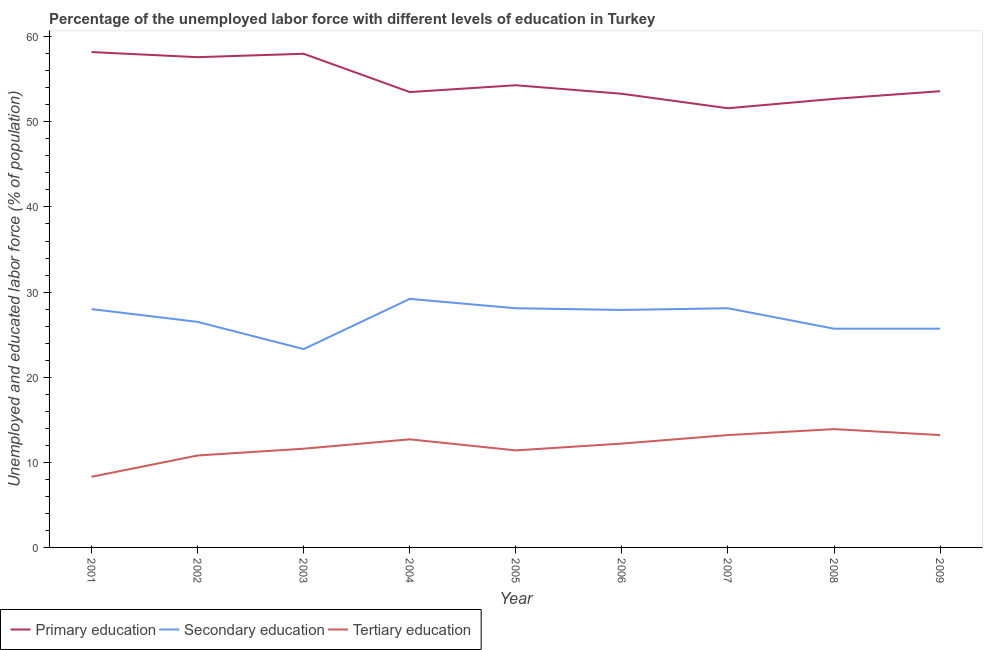How many different coloured lines are there?
Keep it short and to the point. 3. What is the percentage of labor force who received primary education in 2009?
Ensure brevity in your answer.  53.6. Across all years, what is the maximum percentage of labor force who received secondary education?
Keep it short and to the point. 29.2. Across all years, what is the minimum percentage of labor force who received primary education?
Make the answer very short. 51.6. In which year was the percentage of labor force who received primary education maximum?
Give a very brief answer. 2001. In which year was the percentage of labor force who received secondary education minimum?
Your response must be concise. 2003. What is the total percentage of labor force who received secondary education in the graph?
Provide a succinct answer. 242.5. What is the difference between the percentage of labor force who received secondary education in 2001 and that in 2003?
Provide a succinct answer. 4.7. What is the difference between the percentage of labor force who received primary education in 2008 and the percentage of labor force who received tertiary education in 2001?
Offer a terse response. 44.4. What is the average percentage of labor force who received tertiary education per year?
Keep it short and to the point. 11.92. In the year 2001, what is the difference between the percentage of labor force who received secondary education and percentage of labor force who received tertiary education?
Give a very brief answer. 19.7. What is the ratio of the percentage of labor force who received secondary education in 2001 to that in 2005?
Your answer should be very brief. 1. What is the difference between the highest and the second highest percentage of labor force who received secondary education?
Give a very brief answer. 1.1. What is the difference between the highest and the lowest percentage of labor force who received secondary education?
Offer a very short reply. 5.9. In how many years, is the percentage of labor force who received secondary education greater than the average percentage of labor force who received secondary education taken over all years?
Your response must be concise. 5. Is the sum of the percentage of labor force who received primary education in 2001 and 2004 greater than the maximum percentage of labor force who received secondary education across all years?
Ensure brevity in your answer.  Yes. Is it the case that in every year, the sum of the percentage of labor force who received primary education and percentage of labor force who received secondary education is greater than the percentage of labor force who received tertiary education?
Give a very brief answer. Yes. Does the percentage of labor force who received tertiary education monotonically increase over the years?
Your answer should be compact. No. Is the percentage of labor force who received tertiary education strictly less than the percentage of labor force who received secondary education over the years?
Make the answer very short. Yes. What is the difference between two consecutive major ticks on the Y-axis?
Ensure brevity in your answer.  10. Are the values on the major ticks of Y-axis written in scientific E-notation?
Keep it short and to the point. No. What is the title of the graph?
Keep it short and to the point. Percentage of the unemployed labor force with different levels of education in Turkey. Does "Machinery" appear as one of the legend labels in the graph?
Keep it short and to the point. No. What is the label or title of the X-axis?
Your response must be concise. Year. What is the label or title of the Y-axis?
Give a very brief answer. Unemployed and educated labor force (% of population). What is the Unemployed and educated labor force (% of population) of Primary education in 2001?
Provide a succinct answer. 58.2. What is the Unemployed and educated labor force (% of population) of Secondary education in 2001?
Your response must be concise. 28. What is the Unemployed and educated labor force (% of population) in Tertiary education in 2001?
Make the answer very short. 8.3. What is the Unemployed and educated labor force (% of population) of Primary education in 2002?
Your answer should be very brief. 57.6. What is the Unemployed and educated labor force (% of population) in Tertiary education in 2002?
Your answer should be compact. 10.8. What is the Unemployed and educated labor force (% of population) in Secondary education in 2003?
Your response must be concise. 23.3. What is the Unemployed and educated labor force (% of population) of Tertiary education in 2003?
Your answer should be very brief. 11.6. What is the Unemployed and educated labor force (% of population) in Primary education in 2004?
Give a very brief answer. 53.5. What is the Unemployed and educated labor force (% of population) in Secondary education in 2004?
Offer a terse response. 29.2. What is the Unemployed and educated labor force (% of population) in Tertiary education in 2004?
Your response must be concise. 12.7. What is the Unemployed and educated labor force (% of population) of Primary education in 2005?
Your answer should be very brief. 54.3. What is the Unemployed and educated labor force (% of population) of Secondary education in 2005?
Your answer should be compact. 28.1. What is the Unemployed and educated labor force (% of population) in Tertiary education in 2005?
Keep it short and to the point. 11.4. What is the Unemployed and educated labor force (% of population) of Primary education in 2006?
Give a very brief answer. 53.3. What is the Unemployed and educated labor force (% of population) of Secondary education in 2006?
Give a very brief answer. 27.9. What is the Unemployed and educated labor force (% of population) of Tertiary education in 2006?
Keep it short and to the point. 12.2. What is the Unemployed and educated labor force (% of population) in Primary education in 2007?
Offer a very short reply. 51.6. What is the Unemployed and educated labor force (% of population) of Secondary education in 2007?
Give a very brief answer. 28.1. What is the Unemployed and educated labor force (% of population) of Tertiary education in 2007?
Make the answer very short. 13.2. What is the Unemployed and educated labor force (% of population) in Primary education in 2008?
Provide a succinct answer. 52.7. What is the Unemployed and educated labor force (% of population) of Secondary education in 2008?
Offer a terse response. 25.7. What is the Unemployed and educated labor force (% of population) in Tertiary education in 2008?
Keep it short and to the point. 13.9. What is the Unemployed and educated labor force (% of population) in Primary education in 2009?
Offer a very short reply. 53.6. What is the Unemployed and educated labor force (% of population) in Secondary education in 2009?
Offer a very short reply. 25.7. What is the Unemployed and educated labor force (% of population) in Tertiary education in 2009?
Your response must be concise. 13.2. Across all years, what is the maximum Unemployed and educated labor force (% of population) in Primary education?
Provide a short and direct response. 58.2. Across all years, what is the maximum Unemployed and educated labor force (% of population) of Secondary education?
Keep it short and to the point. 29.2. Across all years, what is the maximum Unemployed and educated labor force (% of population) of Tertiary education?
Your response must be concise. 13.9. Across all years, what is the minimum Unemployed and educated labor force (% of population) in Primary education?
Keep it short and to the point. 51.6. Across all years, what is the minimum Unemployed and educated labor force (% of population) in Secondary education?
Give a very brief answer. 23.3. Across all years, what is the minimum Unemployed and educated labor force (% of population) in Tertiary education?
Ensure brevity in your answer.  8.3. What is the total Unemployed and educated labor force (% of population) of Primary education in the graph?
Ensure brevity in your answer.  492.8. What is the total Unemployed and educated labor force (% of population) in Secondary education in the graph?
Offer a terse response. 242.5. What is the total Unemployed and educated labor force (% of population) of Tertiary education in the graph?
Offer a very short reply. 107.3. What is the difference between the Unemployed and educated labor force (% of population) in Tertiary education in 2001 and that in 2002?
Make the answer very short. -2.5. What is the difference between the Unemployed and educated labor force (% of population) in Primary education in 2001 and that in 2003?
Give a very brief answer. 0.2. What is the difference between the Unemployed and educated labor force (% of population) of Secondary education in 2001 and that in 2003?
Offer a very short reply. 4.7. What is the difference between the Unemployed and educated labor force (% of population) of Tertiary education in 2001 and that in 2003?
Give a very brief answer. -3.3. What is the difference between the Unemployed and educated labor force (% of population) of Secondary education in 2001 and that in 2004?
Your answer should be compact. -1.2. What is the difference between the Unemployed and educated labor force (% of population) of Primary education in 2001 and that in 2005?
Keep it short and to the point. 3.9. What is the difference between the Unemployed and educated labor force (% of population) of Secondary education in 2001 and that in 2005?
Provide a short and direct response. -0.1. What is the difference between the Unemployed and educated labor force (% of population) of Tertiary education in 2001 and that in 2005?
Offer a terse response. -3.1. What is the difference between the Unemployed and educated labor force (% of population) in Primary education in 2001 and that in 2006?
Give a very brief answer. 4.9. What is the difference between the Unemployed and educated labor force (% of population) in Primary education in 2001 and that in 2007?
Provide a succinct answer. 6.6. What is the difference between the Unemployed and educated labor force (% of population) of Tertiary education in 2001 and that in 2007?
Your answer should be compact. -4.9. What is the difference between the Unemployed and educated labor force (% of population) in Secondary education in 2001 and that in 2008?
Provide a short and direct response. 2.3. What is the difference between the Unemployed and educated labor force (% of population) of Tertiary education in 2001 and that in 2008?
Your answer should be very brief. -5.6. What is the difference between the Unemployed and educated labor force (% of population) in Primary education in 2001 and that in 2009?
Keep it short and to the point. 4.6. What is the difference between the Unemployed and educated labor force (% of population) of Tertiary education in 2001 and that in 2009?
Provide a short and direct response. -4.9. What is the difference between the Unemployed and educated labor force (% of population) of Primary education in 2002 and that in 2003?
Offer a very short reply. -0.4. What is the difference between the Unemployed and educated labor force (% of population) in Primary education in 2002 and that in 2004?
Your answer should be compact. 4.1. What is the difference between the Unemployed and educated labor force (% of population) of Secondary education in 2002 and that in 2004?
Provide a succinct answer. -2.7. What is the difference between the Unemployed and educated labor force (% of population) in Tertiary education in 2002 and that in 2004?
Your answer should be compact. -1.9. What is the difference between the Unemployed and educated labor force (% of population) of Secondary education in 2002 and that in 2005?
Your response must be concise. -1.6. What is the difference between the Unemployed and educated labor force (% of population) of Tertiary education in 2002 and that in 2005?
Provide a succinct answer. -0.6. What is the difference between the Unemployed and educated labor force (% of population) of Primary education in 2002 and that in 2006?
Your answer should be compact. 4.3. What is the difference between the Unemployed and educated labor force (% of population) of Secondary education in 2002 and that in 2006?
Provide a short and direct response. -1.4. What is the difference between the Unemployed and educated labor force (% of population) in Primary education in 2002 and that in 2007?
Your answer should be compact. 6. What is the difference between the Unemployed and educated labor force (% of population) in Tertiary education in 2002 and that in 2008?
Make the answer very short. -3.1. What is the difference between the Unemployed and educated labor force (% of population) in Primary education in 2002 and that in 2009?
Offer a very short reply. 4. What is the difference between the Unemployed and educated labor force (% of population) in Tertiary education in 2003 and that in 2004?
Your answer should be very brief. -1.1. What is the difference between the Unemployed and educated labor force (% of population) of Primary education in 2003 and that in 2005?
Ensure brevity in your answer.  3.7. What is the difference between the Unemployed and educated labor force (% of population) in Primary education in 2003 and that in 2006?
Keep it short and to the point. 4.7. What is the difference between the Unemployed and educated labor force (% of population) of Secondary education in 2003 and that in 2007?
Offer a terse response. -4.8. What is the difference between the Unemployed and educated labor force (% of population) in Secondary education in 2003 and that in 2009?
Make the answer very short. -2.4. What is the difference between the Unemployed and educated labor force (% of population) of Primary education in 2004 and that in 2005?
Your answer should be very brief. -0.8. What is the difference between the Unemployed and educated labor force (% of population) of Secondary education in 2004 and that in 2005?
Offer a terse response. 1.1. What is the difference between the Unemployed and educated labor force (% of population) in Tertiary education in 2004 and that in 2005?
Make the answer very short. 1.3. What is the difference between the Unemployed and educated labor force (% of population) in Primary education in 2004 and that in 2006?
Offer a terse response. 0.2. What is the difference between the Unemployed and educated labor force (% of population) of Secondary education in 2004 and that in 2006?
Provide a short and direct response. 1.3. What is the difference between the Unemployed and educated labor force (% of population) in Secondary education in 2004 and that in 2007?
Your answer should be compact. 1.1. What is the difference between the Unemployed and educated labor force (% of population) of Tertiary education in 2004 and that in 2007?
Give a very brief answer. -0.5. What is the difference between the Unemployed and educated labor force (% of population) in Secondary education in 2004 and that in 2008?
Provide a succinct answer. 3.5. What is the difference between the Unemployed and educated labor force (% of population) in Tertiary education in 2004 and that in 2008?
Offer a very short reply. -1.2. What is the difference between the Unemployed and educated labor force (% of population) of Primary education in 2004 and that in 2009?
Keep it short and to the point. -0.1. What is the difference between the Unemployed and educated labor force (% of population) of Tertiary education in 2004 and that in 2009?
Provide a succinct answer. -0.5. What is the difference between the Unemployed and educated labor force (% of population) of Secondary education in 2005 and that in 2006?
Provide a succinct answer. 0.2. What is the difference between the Unemployed and educated labor force (% of population) in Tertiary education in 2005 and that in 2006?
Offer a very short reply. -0.8. What is the difference between the Unemployed and educated labor force (% of population) in Primary education in 2005 and that in 2008?
Your answer should be very brief. 1.6. What is the difference between the Unemployed and educated labor force (% of population) of Secondary education in 2006 and that in 2007?
Make the answer very short. -0.2. What is the difference between the Unemployed and educated labor force (% of population) in Tertiary education in 2006 and that in 2007?
Ensure brevity in your answer.  -1. What is the difference between the Unemployed and educated labor force (% of population) of Secondary education in 2006 and that in 2008?
Give a very brief answer. 2.2. What is the difference between the Unemployed and educated labor force (% of population) in Tertiary education in 2006 and that in 2008?
Offer a terse response. -1.7. What is the difference between the Unemployed and educated labor force (% of population) of Primary education in 2006 and that in 2009?
Your answer should be very brief. -0.3. What is the difference between the Unemployed and educated labor force (% of population) of Primary education in 2007 and that in 2009?
Your answer should be very brief. -2. What is the difference between the Unemployed and educated labor force (% of population) of Secondary education in 2007 and that in 2009?
Make the answer very short. 2.4. What is the difference between the Unemployed and educated labor force (% of population) in Tertiary education in 2007 and that in 2009?
Keep it short and to the point. 0. What is the difference between the Unemployed and educated labor force (% of population) in Primary education in 2008 and that in 2009?
Your answer should be compact. -0.9. What is the difference between the Unemployed and educated labor force (% of population) in Tertiary education in 2008 and that in 2009?
Your response must be concise. 0.7. What is the difference between the Unemployed and educated labor force (% of population) of Primary education in 2001 and the Unemployed and educated labor force (% of population) of Secondary education in 2002?
Your answer should be compact. 31.7. What is the difference between the Unemployed and educated labor force (% of population) in Primary education in 2001 and the Unemployed and educated labor force (% of population) in Tertiary education in 2002?
Ensure brevity in your answer.  47.4. What is the difference between the Unemployed and educated labor force (% of population) in Secondary education in 2001 and the Unemployed and educated labor force (% of population) in Tertiary education in 2002?
Provide a succinct answer. 17.2. What is the difference between the Unemployed and educated labor force (% of population) in Primary education in 2001 and the Unemployed and educated labor force (% of population) in Secondary education in 2003?
Offer a terse response. 34.9. What is the difference between the Unemployed and educated labor force (% of population) in Primary education in 2001 and the Unemployed and educated labor force (% of population) in Tertiary education in 2003?
Your response must be concise. 46.6. What is the difference between the Unemployed and educated labor force (% of population) of Secondary education in 2001 and the Unemployed and educated labor force (% of population) of Tertiary education in 2003?
Provide a short and direct response. 16.4. What is the difference between the Unemployed and educated labor force (% of population) of Primary education in 2001 and the Unemployed and educated labor force (% of population) of Secondary education in 2004?
Ensure brevity in your answer.  29. What is the difference between the Unemployed and educated labor force (% of population) in Primary education in 2001 and the Unemployed and educated labor force (% of population) in Tertiary education in 2004?
Provide a succinct answer. 45.5. What is the difference between the Unemployed and educated labor force (% of population) in Secondary education in 2001 and the Unemployed and educated labor force (% of population) in Tertiary education in 2004?
Keep it short and to the point. 15.3. What is the difference between the Unemployed and educated labor force (% of population) of Primary education in 2001 and the Unemployed and educated labor force (% of population) of Secondary education in 2005?
Offer a very short reply. 30.1. What is the difference between the Unemployed and educated labor force (% of population) of Primary education in 2001 and the Unemployed and educated labor force (% of population) of Tertiary education in 2005?
Give a very brief answer. 46.8. What is the difference between the Unemployed and educated labor force (% of population) of Secondary education in 2001 and the Unemployed and educated labor force (% of population) of Tertiary education in 2005?
Provide a succinct answer. 16.6. What is the difference between the Unemployed and educated labor force (% of population) in Primary education in 2001 and the Unemployed and educated labor force (% of population) in Secondary education in 2006?
Ensure brevity in your answer.  30.3. What is the difference between the Unemployed and educated labor force (% of population) of Secondary education in 2001 and the Unemployed and educated labor force (% of population) of Tertiary education in 2006?
Provide a succinct answer. 15.8. What is the difference between the Unemployed and educated labor force (% of population) of Primary education in 2001 and the Unemployed and educated labor force (% of population) of Secondary education in 2007?
Your answer should be compact. 30.1. What is the difference between the Unemployed and educated labor force (% of population) in Primary education in 2001 and the Unemployed and educated labor force (% of population) in Tertiary education in 2007?
Offer a very short reply. 45. What is the difference between the Unemployed and educated labor force (% of population) of Secondary education in 2001 and the Unemployed and educated labor force (% of population) of Tertiary education in 2007?
Ensure brevity in your answer.  14.8. What is the difference between the Unemployed and educated labor force (% of population) in Primary education in 2001 and the Unemployed and educated labor force (% of population) in Secondary education in 2008?
Your answer should be compact. 32.5. What is the difference between the Unemployed and educated labor force (% of population) in Primary education in 2001 and the Unemployed and educated labor force (% of population) in Tertiary education in 2008?
Your response must be concise. 44.3. What is the difference between the Unemployed and educated labor force (% of population) of Primary education in 2001 and the Unemployed and educated labor force (% of population) of Secondary education in 2009?
Offer a terse response. 32.5. What is the difference between the Unemployed and educated labor force (% of population) in Secondary education in 2001 and the Unemployed and educated labor force (% of population) in Tertiary education in 2009?
Your answer should be compact. 14.8. What is the difference between the Unemployed and educated labor force (% of population) of Primary education in 2002 and the Unemployed and educated labor force (% of population) of Secondary education in 2003?
Your answer should be very brief. 34.3. What is the difference between the Unemployed and educated labor force (% of population) in Primary education in 2002 and the Unemployed and educated labor force (% of population) in Tertiary education in 2003?
Provide a short and direct response. 46. What is the difference between the Unemployed and educated labor force (% of population) of Secondary education in 2002 and the Unemployed and educated labor force (% of population) of Tertiary education in 2003?
Give a very brief answer. 14.9. What is the difference between the Unemployed and educated labor force (% of population) of Primary education in 2002 and the Unemployed and educated labor force (% of population) of Secondary education in 2004?
Provide a short and direct response. 28.4. What is the difference between the Unemployed and educated labor force (% of population) in Primary education in 2002 and the Unemployed and educated labor force (% of population) in Tertiary education in 2004?
Provide a short and direct response. 44.9. What is the difference between the Unemployed and educated labor force (% of population) of Secondary education in 2002 and the Unemployed and educated labor force (% of population) of Tertiary education in 2004?
Offer a very short reply. 13.8. What is the difference between the Unemployed and educated labor force (% of population) in Primary education in 2002 and the Unemployed and educated labor force (% of population) in Secondary education in 2005?
Provide a short and direct response. 29.5. What is the difference between the Unemployed and educated labor force (% of population) in Primary education in 2002 and the Unemployed and educated labor force (% of population) in Tertiary education in 2005?
Make the answer very short. 46.2. What is the difference between the Unemployed and educated labor force (% of population) in Secondary education in 2002 and the Unemployed and educated labor force (% of population) in Tertiary education in 2005?
Give a very brief answer. 15.1. What is the difference between the Unemployed and educated labor force (% of population) in Primary education in 2002 and the Unemployed and educated labor force (% of population) in Secondary education in 2006?
Your answer should be very brief. 29.7. What is the difference between the Unemployed and educated labor force (% of population) of Primary education in 2002 and the Unemployed and educated labor force (% of population) of Tertiary education in 2006?
Give a very brief answer. 45.4. What is the difference between the Unemployed and educated labor force (% of population) in Primary education in 2002 and the Unemployed and educated labor force (% of population) in Secondary education in 2007?
Your answer should be compact. 29.5. What is the difference between the Unemployed and educated labor force (% of population) in Primary education in 2002 and the Unemployed and educated labor force (% of population) in Tertiary education in 2007?
Offer a terse response. 44.4. What is the difference between the Unemployed and educated labor force (% of population) in Secondary education in 2002 and the Unemployed and educated labor force (% of population) in Tertiary education in 2007?
Provide a succinct answer. 13.3. What is the difference between the Unemployed and educated labor force (% of population) in Primary education in 2002 and the Unemployed and educated labor force (% of population) in Secondary education in 2008?
Offer a very short reply. 31.9. What is the difference between the Unemployed and educated labor force (% of population) in Primary education in 2002 and the Unemployed and educated labor force (% of population) in Tertiary education in 2008?
Your answer should be compact. 43.7. What is the difference between the Unemployed and educated labor force (% of population) of Primary education in 2002 and the Unemployed and educated labor force (% of population) of Secondary education in 2009?
Offer a terse response. 31.9. What is the difference between the Unemployed and educated labor force (% of population) in Primary education in 2002 and the Unemployed and educated labor force (% of population) in Tertiary education in 2009?
Offer a very short reply. 44.4. What is the difference between the Unemployed and educated labor force (% of population) in Secondary education in 2002 and the Unemployed and educated labor force (% of population) in Tertiary education in 2009?
Provide a short and direct response. 13.3. What is the difference between the Unemployed and educated labor force (% of population) of Primary education in 2003 and the Unemployed and educated labor force (% of population) of Secondary education in 2004?
Ensure brevity in your answer.  28.8. What is the difference between the Unemployed and educated labor force (% of population) of Primary education in 2003 and the Unemployed and educated labor force (% of population) of Tertiary education in 2004?
Offer a very short reply. 45.3. What is the difference between the Unemployed and educated labor force (% of population) of Secondary education in 2003 and the Unemployed and educated labor force (% of population) of Tertiary education in 2004?
Provide a succinct answer. 10.6. What is the difference between the Unemployed and educated labor force (% of population) in Primary education in 2003 and the Unemployed and educated labor force (% of population) in Secondary education in 2005?
Offer a terse response. 29.9. What is the difference between the Unemployed and educated labor force (% of population) in Primary education in 2003 and the Unemployed and educated labor force (% of population) in Tertiary education in 2005?
Your answer should be very brief. 46.6. What is the difference between the Unemployed and educated labor force (% of population) of Secondary education in 2003 and the Unemployed and educated labor force (% of population) of Tertiary education in 2005?
Give a very brief answer. 11.9. What is the difference between the Unemployed and educated labor force (% of population) of Primary education in 2003 and the Unemployed and educated labor force (% of population) of Secondary education in 2006?
Give a very brief answer. 30.1. What is the difference between the Unemployed and educated labor force (% of population) in Primary education in 2003 and the Unemployed and educated labor force (% of population) in Tertiary education in 2006?
Ensure brevity in your answer.  45.8. What is the difference between the Unemployed and educated labor force (% of population) of Primary education in 2003 and the Unemployed and educated labor force (% of population) of Secondary education in 2007?
Offer a very short reply. 29.9. What is the difference between the Unemployed and educated labor force (% of population) in Primary education in 2003 and the Unemployed and educated labor force (% of population) in Tertiary education in 2007?
Make the answer very short. 44.8. What is the difference between the Unemployed and educated labor force (% of population) of Primary education in 2003 and the Unemployed and educated labor force (% of population) of Secondary education in 2008?
Ensure brevity in your answer.  32.3. What is the difference between the Unemployed and educated labor force (% of population) of Primary education in 2003 and the Unemployed and educated labor force (% of population) of Tertiary education in 2008?
Offer a terse response. 44.1. What is the difference between the Unemployed and educated labor force (% of population) in Primary education in 2003 and the Unemployed and educated labor force (% of population) in Secondary education in 2009?
Offer a terse response. 32.3. What is the difference between the Unemployed and educated labor force (% of population) of Primary education in 2003 and the Unemployed and educated labor force (% of population) of Tertiary education in 2009?
Ensure brevity in your answer.  44.8. What is the difference between the Unemployed and educated labor force (% of population) in Primary education in 2004 and the Unemployed and educated labor force (% of population) in Secondary education in 2005?
Your response must be concise. 25.4. What is the difference between the Unemployed and educated labor force (% of population) in Primary education in 2004 and the Unemployed and educated labor force (% of population) in Tertiary education in 2005?
Offer a terse response. 42.1. What is the difference between the Unemployed and educated labor force (% of population) in Secondary education in 2004 and the Unemployed and educated labor force (% of population) in Tertiary education in 2005?
Provide a succinct answer. 17.8. What is the difference between the Unemployed and educated labor force (% of population) of Primary education in 2004 and the Unemployed and educated labor force (% of population) of Secondary education in 2006?
Ensure brevity in your answer.  25.6. What is the difference between the Unemployed and educated labor force (% of population) in Primary education in 2004 and the Unemployed and educated labor force (% of population) in Tertiary education in 2006?
Offer a very short reply. 41.3. What is the difference between the Unemployed and educated labor force (% of population) of Secondary education in 2004 and the Unemployed and educated labor force (% of population) of Tertiary education in 2006?
Give a very brief answer. 17. What is the difference between the Unemployed and educated labor force (% of population) of Primary education in 2004 and the Unemployed and educated labor force (% of population) of Secondary education in 2007?
Keep it short and to the point. 25.4. What is the difference between the Unemployed and educated labor force (% of population) of Primary education in 2004 and the Unemployed and educated labor force (% of population) of Tertiary education in 2007?
Offer a terse response. 40.3. What is the difference between the Unemployed and educated labor force (% of population) of Primary education in 2004 and the Unemployed and educated labor force (% of population) of Secondary education in 2008?
Keep it short and to the point. 27.8. What is the difference between the Unemployed and educated labor force (% of population) of Primary education in 2004 and the Unemployed and educated labor force (% of population) of Tertiary education in 2008?
Make the answer very short. 39.6. What is the difference between the Unemployed and educated labor force (% of population) in Secondary education in 2004 and the Unemployed and educated labor force (% of population) in Tertiary education in 2008?
Keep it short and to the point. 15.3. What is the difference between the Unemployed and educated labor force (% of population) of Primary education in 2004 and the Unemployed and educated labor force (% of population) of Secondary education in 2009?
Your answer should be very brief. 27.8. What is the difference between the Unemployed and educated labor force (% of population) of Primary education in 2004 and the Unemployed and educated labor force (% of population) of Tertiary education in 2009?
Your answer should be very brief. 40.3. What is the difference between the Unemployed and educated labor force (% of population) of Secondary education in 2004 and the Unemployed and educated labor force (% of population) of Tertiary education in 2009?
Offer a very short reply. 16. What is the difference between the Unemployed and educated labor force (% of population) of Primary education in 2005 and the Unemployed and educated labor force (% of population) of Secondary education in 2006?
Ensure brevity in your answer.  26.4. What is the difference between the Unemployed and educated labor force (% of population) of Primary education in 2005 and the Unemployed and educated labor force (% of population) of Tertiary education in 2006?
Your answer should be very brief. 42.1. What is the difference between the Unemployed and educated labor force (% of population) in Secondary education in 2005 and the Unemployed and educated labor force (% of population) in Tertiary education in 2006?
Keep it short and to the point. 15.9. What is the difference between the Unemployed and educated labor force (% of population) in Primary education in 2005 and the Unemployed and educated labor force (% of population) in Secondary education in 2007?
Provide a succinct answer. 26.2. What is the difference between the Unemployed and educated labor force (% of population) in Primary education in 2005 and the Unemployed and educated labor force (% of population) in Tertiary education in 2007?
Keep it short and to the point. 41.1. What is the difference between the Unemployed and educated labor force (% of population) of Primary education in 2005 and the Unemployed and educated labor force (% of population) of Secondary education in 2008?
Offer a terse response. 28.6. What is the difference between the Unemployed and educated labor force (% of population) of Primary education in 2005 and the Unemployed and educated labor force (% of population) of Tertiary education in 2008?
Give a very brief answer. 40.4. What is the difference between the Unemployed and educated labor force (% of population) of Primary education in 2005 and the Unemployed and educated labor force (% of population) of Secondary education in 2009?
Your answer should be very brief. 28.6. What is the difference between the Unemployed and educated labor force (% of population) in Primary education in 2005 and the Unemployed and educated labor force (% of population) in Tertiary education in 2009?
Your response must be concise. 41.1. What is the difference between the Unemployed and educated labor force (% of population) of Secondary education in 2005 and the Unemployed and educated labor force (% of population) of Tertiary education in 2009?
Give a very brief answer. 14.9. What is the difference between the Unemployed and educated labor force (% of population) in Primary education in 2006 and the Unemployed and educated labor force (% of population) in Secondary education in 2007?
Offer a very short reply. 25.2. What is the difference between the Unemployed and educated labor force (% of population) of Primary education in 2006 and the Unemployed and educated labor force (% of population) of Tertiary education in 2007?
Offer a very short reply. 40.1. What is the difference between the Unemployed and educated labor force (% of population) of Secondary education in 2006 and the Unemployed and educated labor force (% of population) of Tertiary education in 2007?
Provide a short and direct response. 14.7. What is the difference between the Unemployed and educated labor force (% of population) of Primary education in 2006 and the Unemployed and educated labor force (% of population) of Secondary education in 2008?
Provide a short and direct response. 27.6. What is the difference between the Unemployed and educated labor force (% of population) of Primary education in 2006 and the Unemployed and educated labor force (% of population) of Tertiary education in 2008?
Ensure brevity in your answer.  39.4. What is the difference between the Unemployed and educated labor force (% of population) in Primary education in 2006 and the Unemployed and educated labor force (% of population) in Secondary education in 2009?
Offer a very short reply. 27.6. What is the difference between the Unemployed and educated labor force (% of population) of Primary education in 2006 and the Unemployed and educated labor force (% of population) of Tertiary education in 2009?
Provide a succinct answer. 40.1. What is the difference between the Unemployed and educated labor force (% of population) of Primary education in 2007 and the Unemployed and educated labor force (% of population) of Secondary education in 2008?
Keep it short and to the point. 25.9. What is the difference between the Unemployed and educated labor force (% of population) of Primary education in 2007 and the Unemployed and educated labor force (% of population) of Tertiary education in 2008?
Your response must be concise. 37.7. What is the difference between the Unemployed and educated labor force (% of population) in Secondary education in 2007 and the Unemployed and educated labor force (% of population) in Tertiary education in 2008?
Your answer should be compact. 14.2. What is the difference between the Unemployed and educated labor force (% of population) of Primary education in 2007 and the Unemployed and educated labor force (% of population) of Secondary education in 2009?
Make the answer very short. 25.9. What is the difference between the Unemployed and educated labor force (% of population) in Primary education in 2007 and the Unemployed and educated labor force (% of population) in Tertiary education in 2009?
Ensure brevity in your answer.  38.4. What is the difference between the Unemployed and educated labor force (% of population) of Secondary education in 2007 and the Unemployed and educated labor force (% of population) of Tertiary education in 2009?
Provide a succinct answer. 14.9. What is the difference between the Unemployed and educated labor force (% of population) in Primary education in 2008 and the Unemployed and educated labor force (% of population) in Secondary education in 2009?
Your response must be concise. 27. What is the difference between the Unemployed and educated labor force (% of population) in Primary education in 2008 and the Unemployed and educated labor force (% of population) in Tertiary education in 2009?
Ensure brevity in your answer.  39.5. What is the difference between the Unemployed and educated labor force (% of population) in Secondary education in 2008 and the Unemployed and educated labor force (% of population) in Tertiary education in 2009?
Make the answer very short. 12.5. What is the average Unemployed and educated labor force (% of population) in Primary education per year?
Your answer should be very brief. 54.76. What is the average Unemployed and educated labor force (% of population) of Secondary education per year?
Your response must be concise. 26.94. What is the average Unemployed and educated labor force (% of population) of Tertiary education per year?
Your answer should be very brief. 11.92. In the year 2001, what is the difference between the Unemployed and educated labor force (% of population) of Primary education and Unemployed and educated labor force (% of population) of Secondary education?
Give a very brief answer. 30.2. In the year 2001, what is the difference between the Unemployed and educated labor force (% of population) of Primary education and Unemployed and educated labor force (% of population) of Tertiary education?
Your answer should be very brief. 49.9. In the year 2001, what is the difference between the Unemployed and educated labor force (% of population) of Secondary education and Unemployed and educated labor force (% of population) of Tertiary education?
Provide a succinct answer. 19.7. In the year 2002, what is the difference between the Unemployed and educated labor force (% of population) of Primary education and Unemployed and educated labor force (% of population) of Secondary education?
Offer a very short reply. 31.1. In the year 2002, what is the difference between the Unemployed and educated labor force (% of population) in Primary education and Unemployed and educated labor force (% of population) in Tertiary education?
Provide a short and direct response. 46.8. In the year 2003, what is the difference between the Unemployed and educated labor force (% of population) of Primary education and Unemployed and educated labor force (% of population) of Secondary education?
Ensure brevity in your answer.  34.7. In the year 2003, what is the difference between the Unemployed and educated labor force (% of population) in Primary education and Unemployed and educated labor force (% of population) in Tertiary education?
Provide a succinct answer. 46.4. In the year 2003, what is the difference between the Unemployed and educated labor force (% of population) of Secondary education and Unemployed and educated labor force (% of population) of Tertiary education?
Your answer should be very brief. 11.7. In the year 2004, what is the difference between the Unemployed and educated labor force (% of population) of Primary education and Unemployed and educated labor force (% of population) of Secondary education?
Your answer should be very brief. 24.3. In the year 2004, what is the difference between the Unemployed and educated labor force (% of population) in Primary education and Unemployed and educated labor force (% of population) in Tertiary education?
Provide a succinct answer. 40.8. In the year 2005, what is the difference between the Unemployed and educated labor force (% of population) in Primary education and Unemployed and educated labor force (% of population) in Secondary education?
Keep it short and to the point. 26.2. In the year 2005, what is the difference between the Unemployed and educated labor force (% of population) in Primary education and Unemployed and educated labor force (% of population) in Tertiary education?
Provide a short and direct response. 42.9. In the year 2005, what is the difference between the Unemployed and educated labor force (% of population) in Secondary education and Unemployed and educated labor force (% of population) in Tertiary education?
Keep it short and to the point. 16.7. In the year 2006, what is the difference between the Unemployed and educated labor force (% of population) in Primary education and Unemployed and educated labor force (% of population) in Secondary education?
Offer a terse response. 25.4. In the year 2006, what is the difference between the Unemployed and educated labor force (% of population) in Primary education and Unemployed and educated labor force (% of population) in Tertiary education?
Provide a succinct answer. 41.1. In the year 2007, what is the difference between the Unemployed and educated labor force (% of population) of Primary education and Unemployed and educated labor force (% of population) of Secondary education?
Offer a terse response. 23.5. In the year 2007, what is the difference between the Unemployed and educated labor force (% of population) in Primary education and Unemployed and educated labor force (% of population) in Tertiary education?
Provide a succinct answer. 38.4. In the year 2007, what is the difference between the Unemployed and educated labor force (% of population) of Secondary education and Unemployed and educated labor force (% of population) of Tertiary education?
Make the answer very short. 14.9. In the year 2008, what is the difference between the Unemployed and educated labor force (% of population) of Primary education and Unemployed and educated labor force (% of population) of Tertiary education?
Your response must be concise. 38.8. In the year 2008, what is the difference between the Unemployed and educated labor force (% of population) of Secondary education and Unemployed and educated labor force (% of population) of Tertiary education?
Keep it short and to the point. 11.8. In the year 2009, what is the difference between the Unemployed and educated labor force (% of population) of Primary education and Unemployed and educated labor force (% of population) of Secondary education?
Ensure brevity in your answer.  27.9. In the year 2009, what is the difference between the Unemployed and educated labor force (% of population) of Primary education and Unemployed and educated labor force (% of population) of Tertiary education?
Your answer should be compact. 40.4. What is the ratio of the Unemployed and educated labor force (% of population) in Primary education in 2001 to that in 2002?
Ensure brevity in your answer.  1.01. What is the ratio of the Unemployed and educated labor force (% of population) of Secondary education in 2001 to that in 2002?
Ensure brevity in your answer.  1.06. What is the ratio of the Unemployed and educated labor force (% of population) in Tertiary education in 2001 to that in 2002?
Your response must be concise. 0.77. What is the ratio of the Unemployed and educated labor force (% of population) of Primary education in 2001 to that in 2003?
Make the answer very short. 1. What is the ratio of the Unemployed and educated labor force (% of population) of Secondary education in 2001 to that in 2003?
Offer a very short reply. 1.2. What is the ratio of the Unemployed and educated labor force (% of population) of Tertiary education in 2001 to that in 2003?
Ensure brevity in your answer.  0.72. What is the ratio of the Unemployed and educated labor force (% of population) in Primary education in 2001 to that in 2004?
Make the answer very short. 1.09. What is the ratio of the Unemployed and educated labor force (% of population) of Secondary education in 2001 to that in 2004?
Your answer should be compact. 0.96. What is the ratio of the Unemployed and educated labor force (% of population) of Tertiary education in 2001 to that in 2004?
Offer a very short reply. 0.65. What is the ratio of the Unemployed and educated labor force (% of population) of Primary education in 2001 to that in 2005?
Provide a succinct answer. 1.07. What is the ratio of the Unemployed and educated labor force (% of population) in Tertiary education in 2001 to that in 2005?
Ensure brevity in your answer.  0.73. What is the ratio of the Unemployed and educated labor force (% of population) in Primary education in 2001 to that in 2006?
Keep it short and to the point. 1.09. What is the ratio of the Unemployed and educated labor force (% of population) of Tertiary education in 2001 to that in 2006?
Your answer should be compact. 0.68. What is the ratio of the Unemployed and educated labor force (% of population) of Primary education in 2001 to that in 2007?
Offer a terse response. 1.13. What is the ratio of the Unemployed and educated labor force (% of population) of Tertiary education in 2001 to that in 2007?
Make the answer very short. 0.63. What is the ratio of the Unemployed and educated labor force (% of population) of Primary education in 2001 to that in 2008?
Give a very brief answer. 1.1. What is the ratio of the Unemployed and educated labor force (% of population) in Secondary education in 2001 to that in 2008?
Offer a terse response. 1.09. What is the ratio of the Unemployed and educated labor force (% of population) in Tertiary education in 2001 to that in 2008?
Make the answer very short. 0.6. What is the ratio of the Unemployed and educated labor force (% of population) of Primary education in 2001 to that in 2009?
Your response must be concise. 1.09. What is the ratio of the Unemployed and educated labor force (% of population) in Secondary education in 2001 to that in 2009?
Your answer should be compact. 1.09. What is the ratio of the Unemployed and educated labor force (% of population) in Tertiary education in 2001 to that in 2009?
Your response must be concise. 0.63. What is the ratio of the Unemployed and educated labor force (% of population) of Primary education in 2002 to that in 2003?
Make the answer very short. 0.99. What is the ratio of the Unemployed and educated labor force (% of population) in Secondary education in 2002 to that in 2003?
Make the answer very short. 1.14. What is the ratio of the Unemployed and educated labor force (% of population) of Tertiary education in 2002 to that in 2003?
Offer a terse response. 0.93. What is the ratio of the Unemployed and educated labor force (% of population) in Primary education in 2002 to that in 2004?
Keep it short and to the point. 1.08. What is the ratio of the Unemployed and educated labor force (% of population) of Secondary education in 2002 to that in 2004?
Keep it short and to the point. 0.91. What is the ratio of the Unemployed and educated labor force (% of population) of Tertiary education in 2002 to that in 2004?
Provide a short and direct response. 0.85. What is the ratio of the Unemployed and educated labor force (% of population) in Primary education in 2002 to that in 2005?
Ensure brevity in your answer.  1.06. What is the ratio of the Unemployed and educated labor force (% of population) in Secondary education in 2002 to that in 2005?
Your answer should be compact. 0.94. What is the ratio of the Unemployed and educated labor force (% of population) of Tertiary education in 2002 to that in 2005?
Your response must be concise. 0.95. What is the ratio of the Unemployed and educated labor force (% of population) in Primary education in 2002 to that in 2006?
Offer a very short reply. 1.08. What is the ratio of the Unemployed and educated labor force (% of population) of Secondary education in 2002 to that in 2006?
Ensure brevity in your answer.  0.95. What is the ratio of the Unemployed and educated labor force (% of population) of Tertiary education in 2002 to that in 2006?
Provide a succinct answer. 0.89. What is the ratio of the Unemployed and educated labor force (% of population) of Primary education in 2002 to that in 2007?
Make the answer very short. 1.12. What is the ratio of the Unemployed and educated labor force (% of population) of Secondary education in 2002 to that in 2007?
Your response must be concise. 0.94. What is the ratio of the Unemployed and educated labor force (% of population) of Tertiary education in 2002 to that in 2007?
Give a very brief answer. 0.82. What is the ratio of the Unemployed and educated labor force (% of population) of Primary education in 2002 to that in 2008?
Keep it short and to the point. 1.09. What is the ratio of the Unemployed and educated labor force (% of population) in Secondary education in 2002 to that in 2008?
Give a very brief answer. 1.03. What is the ratio of the Unemployed and educated labor force (% of population) in Tertiary education in 2002 to that in 2008?
Give a very brief answer. 0.78. What is the ratio of the Unemployed and educated labor force (% of population) in Primary education in 2002 to that in 2009?
Your response must be concise. 1.07. What is the ratio of the Unemployed and educated labor force (% of population) in Secondary education in 2002 to that in 2009?
Keep it short and to the point. 1.03. What is the ratio of the Unemployed and educated labor force (% of population) in Tertiary education in 2002 to that in 2009?
Ensure brevity in your answer.  0.82. What is the ratio of the Unemployed and educated labor force (% of population) of Primary education in 2003 to that in 2004?
Make the answer very short. 1.08. What is the ratio of the Unemployed and educated labor force (% of population) in Secondary education in 2003 to that in 2004?
Provide a succinct answer. 0.8. What is the ratio of the Unemployed and educated labor force (% of population) in Tertiary education in 2003 to that in 2004?
Your response must be concise. 0.91. What is the ratio of the Unemployed and educated labor force (% of population) of Primary education in 2003 to that in 2005?
Your answer should be compact. 1.07. What is the ratio of the Unemployed and educated labor force (% of population) in Secondary education in 2003 to that in 2005?
Make the answer very short. 0.83. What is the ratio of the Unemployed and educated labor force (% of population) of Tertiary education in 2003 to that in 2005?
Give a very brief answer. 1.02. What is the ratio of the Unemployed and educated labor force (% of population) of Primary education in 2003 to that in 2006?
Your answer should be compact. 1.09. What is the ratio of the Unemployed and educated labor force (% of population) of Secondary education in 2003 to that in 2006?
Ensure brevity in your answer.  0.84. What is the ratio of the Unemployed and educated labor force (% of population) of Tertiary education in 2003 to that in 2006?
Provide a succinct answer. 0.95. What is the ratio of the Unemployed and educated labor force (% of population) of Primary education in 2003 to that in 2007?
Provide a succinct answer. 1.12. What is the ratio of the Unemployed and educated labor force (% of population) of Secondary education in 2003 to that in 2007?
Offer a terse response. 0.83. What is the ratio of the Unemployed and educated labor force (% of population) of Tertiary education in 2003 to that in 2007?
Offer a very short reply. 0.88. What is the ratio of the Unemployed and educated labor force (% of population) in Primary education in 2003 to that in 2008?
Your answer should be very brief. 1.1. What is the ratio of the Unemployed and educated labor force (% of population) of Secondary education in 2003 to that in 2008?
Your response must be concise. 0.91. What is the ratio of the Unemployed and educated labor force (% of population) of Tertiary education in 2003 to that in 2008?
Provide a succinct answer. 0.83. What is the ratio of the Unemployed and educated labor force (% of population) in Primary education in 2003 to that in 2009?
Provide a short and direct response. 1.08. What is the ratio of the Unemployed and educated labor force (% of population) in Secondary education in 2003 to that in 2009?
Offer a very short reply. 0.91. What is the ratio of the Unemployed and educated labor force (% of population) in Tertiary education in 2003 to that in 2009?
Keep it short and to the point. 0.88. What is the ratio of the Unemployed and educated labor force (% of population) of Primary education in 2004 to that in 2005?
Offer a very short reply. 0.99. What is the ratio of the Unemployed and educated labor force (% of population) of Secondary education in 2004 to that in 2005?
Provide a short and direct response. 1.04. What is the ratio of the Unemployed and educated labor force (% of population) in Tertiary education in 2004 to that in 2005?
Ensure brevity in your answer.  1.11. What is the ratio of the Unemployed and educated labor force (% of population) in Primary education in 2004 to that in 2006?
Offer a terse response. 1. What is the ratio of the Unemployed and educated labor force (% of population) of Secondary education in 2004 to that in 2006?
Provide a succinct answer. 1.05. What is the ratio of the Unemployed and educated labor force (% of population) in Tertiary education in 2004 to that in 2006?
Offer a terse response. 1.04. What is the ratio of the Unemployed and educated labor force (% of population) in Primary education in 2004 to that in 2007?
Offer a very short reply. 1.04. What is the ratio of the Unemployed and educated labor force (% of population) of Secondary education in 2004 to that in 2007?
Provide a succinct answer. 1.04. What is the ratio of the Unemployed and educated labor force (% of population) in Tertiary education in 2004 to that in 2007?
Keep it short and to the point. 0.96. What is the ratio of the Unemployed and educated labor force (% of population) in Primary education in 2004 to that in 2008?
Ensure brevity in your answer.  1.02. What is the ratio of the Unemployed and educated labor force (% of population) of Secondary education in 2004 to that in 2008?
Keep it short and to the point. 1.14. What is the ratio of the Unemployed and educated labor force (% of population) of Tertiary education in 2004 to that in 2008?
Keep it short and to the point. 0.91. What is the ratio of the Unemployed and educated labor force (% of population) in Secondary education in 2004 to that in 2009?
Give a very brief answer. 1.14. What is the ratio of the Unemployed and educated labor force (% of population) of Tertiary education in 2004 to that in 2009?
Ensure brevity in your answer.  0.96. What is the ratio of the Unemployed and educated labor force (% of population) in Primary education in 2005 to that in 2006?
Make the answer very short. 1.02. What is the ratio of the Unemployed and educated labor force (% of population) in Secondary education in 2005 to that in 2006?
Keep it short and to the point. 1.01. What is the ratio of the Unemployed and educated labor force (% of population) in Tertiary education in 2005 to that in 2006?
Provide a succinct answer. 0.93. What is the ratio of the Unemployed and educated labor force (% of population) of Primary education in 2005 to that in 2007?
Make the answer very short. 1.05. What is the ratio of the Unemployed and educated labor force (% of population) of Tertiary education in 2005 to that in 2007?
Your answer should be very brief. 0.86. What is the ratio of the Unemployed and educated labor force (% of population) of Primary education in 2005 to that in 2008?
Ensure brevity in your answer.  1.03. What is the ratio of the Unemployed and educated labor force (% of population) of Secondary education in 2005 to that in 2008?
Your answer should be very brief. 1.09. What is the ratio of the Unemployed and educated labor force (% of population) of Tertiary education in 2005 to that in 2008?
Ensure brevity in your answer.  0.82. What is the ratio of the Unemployed and educated labor force (% of population) in Primary education in 2005 to that in 2009?
Your answer should be compact. 1.01. What is the ratio of the Unemployed and educated labor force (% of population) of Secondary education in 2005 to that in 2009?
Provide a short and direct response. 1.09. What is the ratio of the Unemployed and educated labor force (% of population) of Tertiary education in 2005 to that in 2009?
Your answer should be compact. 0.86. What is the ratio of the Unemployed and educated labor force (% of population) of Primary education in 2006 to that in 2007?
Make the answer very short. 1.03. What is the ratio of the Unemployed and educated labor force (% of population) in Secondary education in 2006 to that in 2007?
Give a very brief answer. 0.99. What is the ratio of the Unemployed and educated labor force (% of population) of Tertiary education in 2006 to that in 2007?
Your answer should be compact. 0.92. What is the ratio of the Unemployed and educated labor force (% of population) of Primary education in 2006 to that in 2008?
Give a very brief answer. 1.01. What is the ratio of the Unemployed and educated labor force (% of population) in Secondary education in 2006 to that in 2008?
Make the answer very short. 1.09. What is the ratio of the Unemployed and educated labor force (% of population) in Tertiary education in 2006 to that in 2008?
Make the answer very short. 0.88. What is the ratio of the Unemployed and educated labor force (% of population) of Secondary education in 2006 to that in 2009?
Your answer should be very brief. 1.09. What is the ratio of the Unemployed and educated labor force (% of population) in Tertiary education in 2006 to that in 2009?
Offer a very short reply. 0.92. What is the ratio of the Unemployed and educated labor force (% of population) in Primary education in 2007 to that in 2008?
Your response must be concise. 0.98. What is the ratio of the Unemployed and educated labor force (% of population) in Secondary education in 2007 to that in 2008?
Give a very brief answer. 1.09. What is the ratio of the Unemployed and educated labor force (% of population) of Tertiary education in 2007 to that in 2008?
Offer a terse response. 0.95. What is the ratio of the Unemployed and educated labor force (% of population) of Primary education in 2007 to that in 2009?
Offer a very short reply. 0.96. What is the ratio of the Unemployed and educated labor force (% of population) of Secondary education in 2007 to that in 2009?
Offer a very short reply. 1.09. What is the ratio of the Unemployed and educated labor force (% of population) in Tertiary education in 2007 to that in 2009?
Your response must be concise. 1. What is the ratio of the Unemployed and educated labor force (% of population) of Primary education in 2008 to that in 2009?
Offer a terse response. 0.98. What is the ratio of the Unemployed and educated labor force (% of population) in Tertiary education in 2008 to that in 2009?
Make the answer very short. 1.05. What is the difference between the highest and the second highest Unemployed and educated labor force (% of population) in Primary education?
Your response must be concise. 0.2. What is the difference between the highest and the second highest Unemployed and educated labor force (% of population) of Tertiary education?
Make the answer very short. 0.7. What is the difference between the highest and the lowest Unemployed and educated labor force (% of population) of Primary education?
Keep it short and to the point. 6.6. 